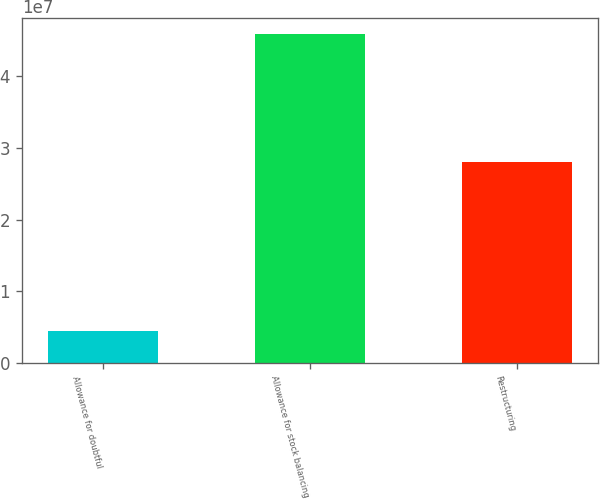<chart> <loc_0><loc_0><loc_500><loc_500><bar_chart><fcel>Allowance for doubtful<fcel>Allowance for stock balancing<fcel>Restructuring<nl><fcel>4.519e+06<fcel>4.5876e+07<fcel>2.8097e+07<nl></chart> 